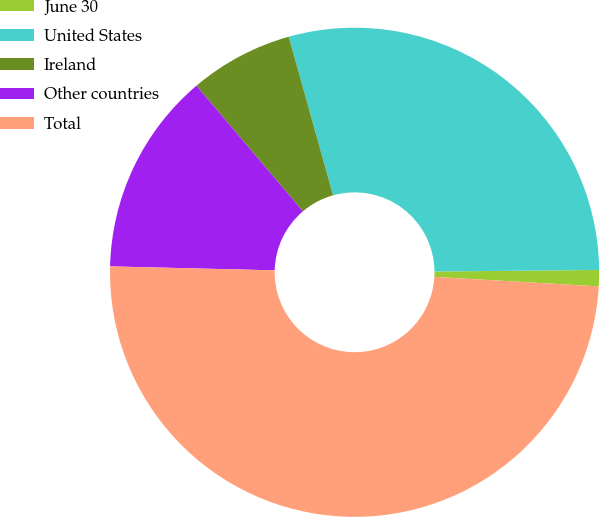Convert chart. <chart><loc_0><loc_0><loc_500><loc_500><pie_chart><fcel>June 30<fcel>United States<fcel>Ireland<fcel>Other countries<fcel>Total<nl><fcel>1.07%<fcel>29.19%<fcel>6.85%<fcel>13.43%<fcel>49.47%<nl></chart> 